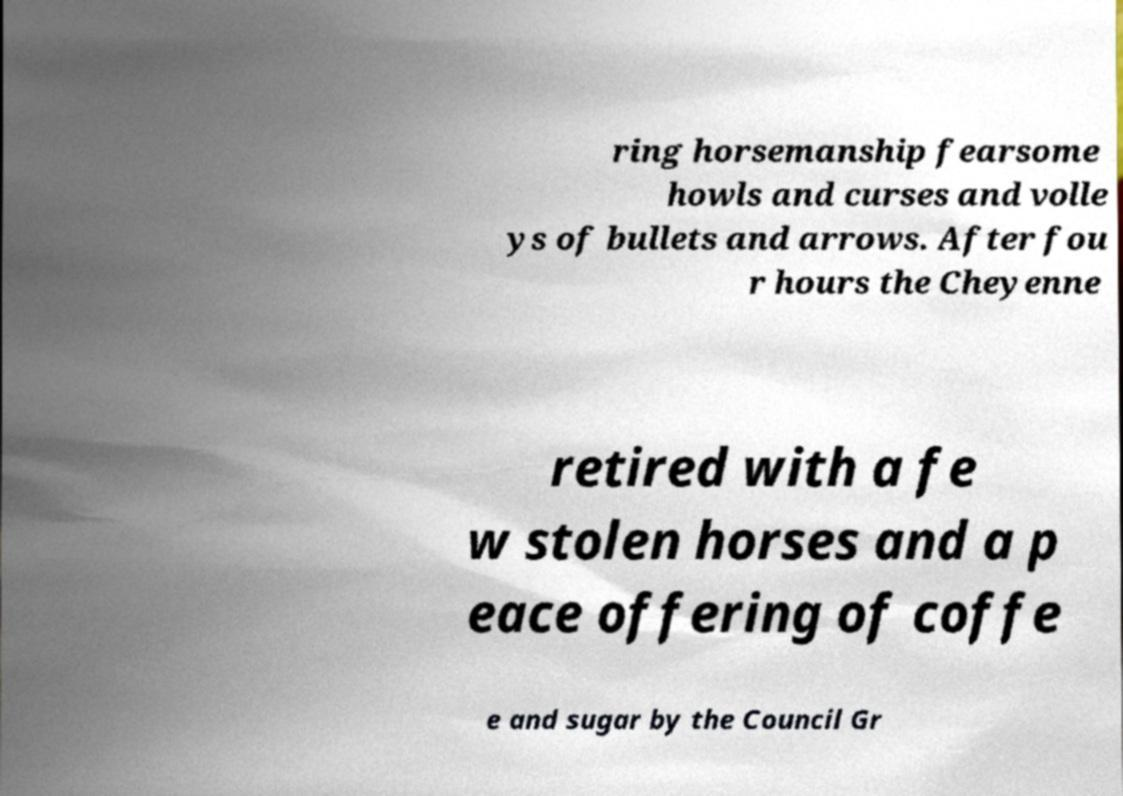I need the written content from this picture converted into text. Can you do that? ring horsemanship fearsome howls and curses and volle ys of bullets and arrows. After fou r hours the Cheyenne retired with a fe w stolen horses and a p eace offering of coffe e and sugar by the Council Gr 